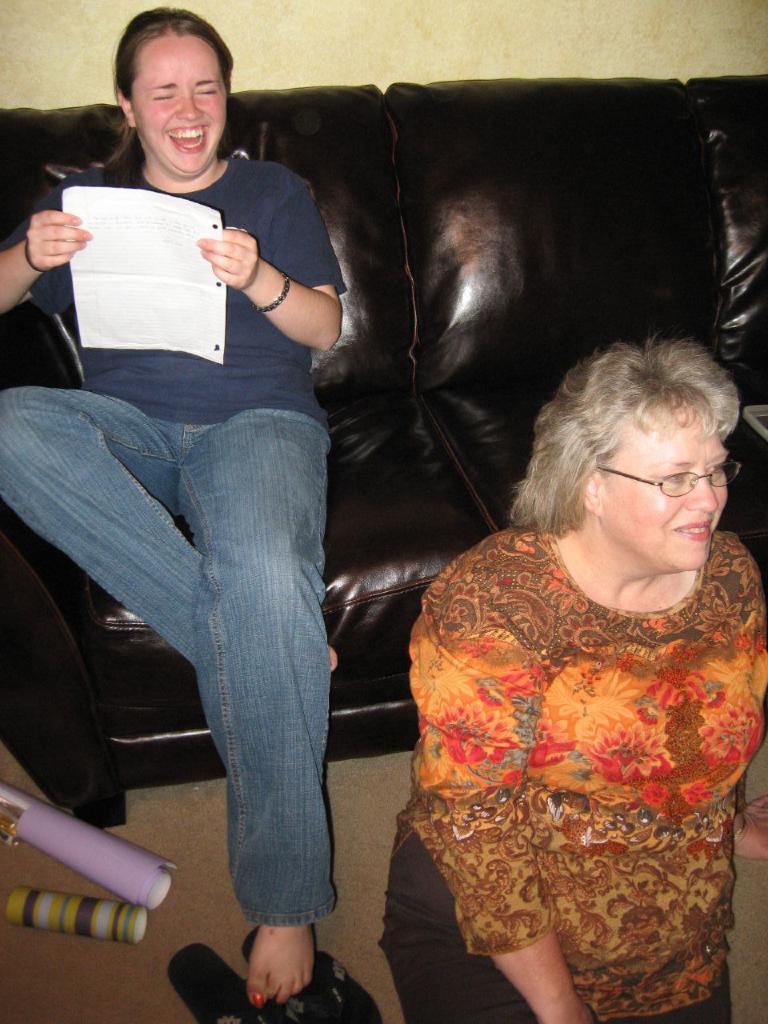In one or two sentences, can you explain what this image depicts? On the left side, there is a woman in a jean pant, holding a paper, smiling and sitting on a sofa. On the right side, there is another woman wearing a spectacle and smiling on the floor, on which there are some objects. In the background, there is a wall. 